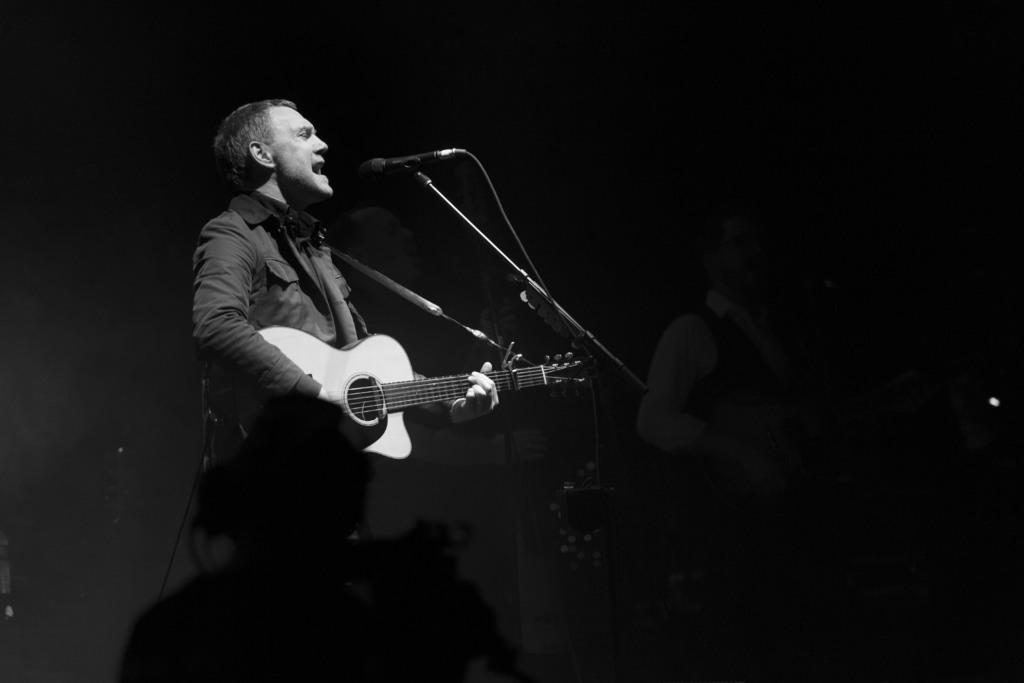Who is the main subject in the image? There is a man in the image. What is the man doing in the image? The man is singing and playing a guitar. What tool is the man using to amplify his voice? The man is using a microphone. Can you see any sheep in the image? No, there are no sheep present in the image. What type of vest is the man wearing in the image? The image does not show the man wearing a vest. 